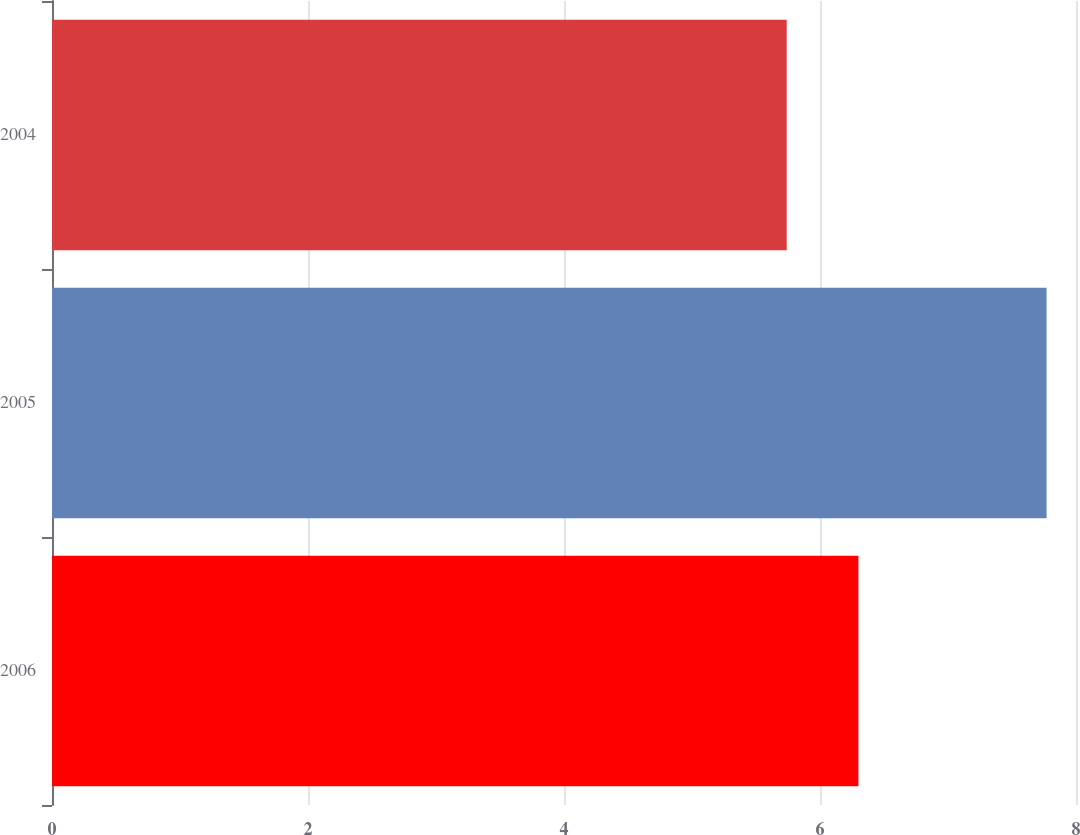Convert chart. <chart><loc_0><loc_0><loc_500><loc_500><bar_chart><fcel>2006<fcel>2005<fcel>2004<nl><fcel>6.3<fcel>7.77<fcel>5.74<nl></chart> 